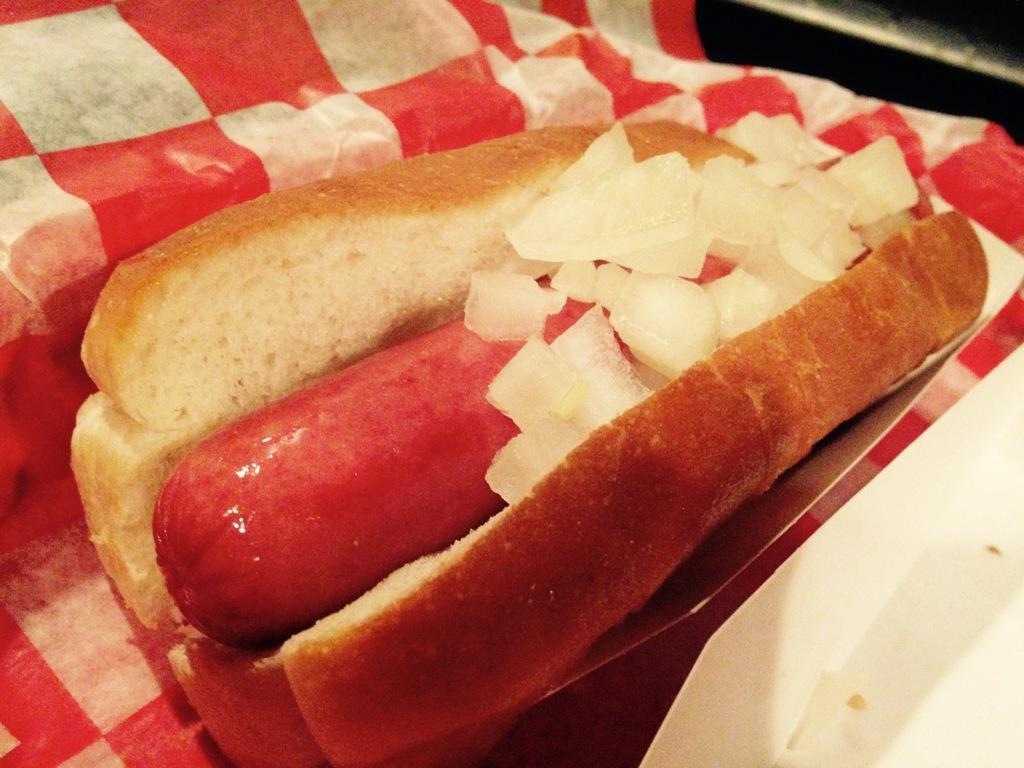How would you summarize this image in a sentence or two? In this picture we can see food items, cloth and some objects. 